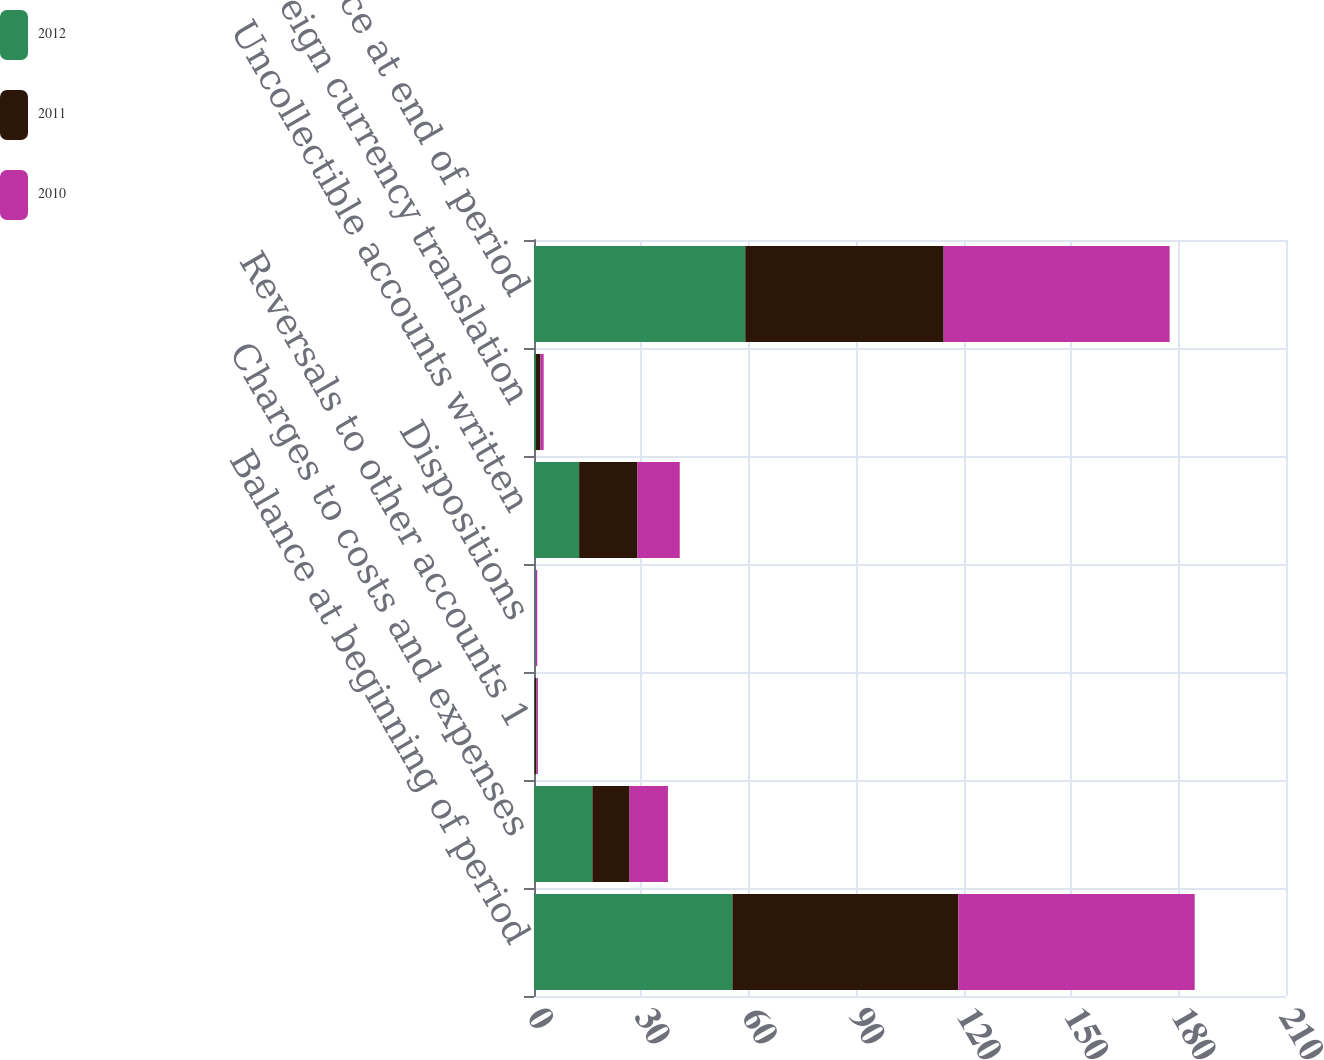<chart> <loc_0><loc_0><loc_500><loc_500><stacked_bar_chart><ecel><fcel>Balance at beginning of period<fcel>Charges to costs and expenses<fcel>Reversals to other accounts 1<fcel>Dispositions<fcel>Uncollectible accounts written<fcel>Foreign currency translation<fcel>Balance at end of period<nl><fcel>2012<fcel>55.4<fcel>16.3<fcel>0.2<fcel>0.4<fcel>12.6<fcel>0.5<fcel>59<nl><fcel>2011<fcel>63.1<fcel>10.4<fcel>0.5<fcel>0<fcel>16.3<fcel>1.3<fcel>55.4<nl><fcel>2010<fcel>66<fcel>10.7<fcel>0.4<fcel>0.5<fcel>11.8<fcel>0.9<fcel>63.1<nl></chart> 